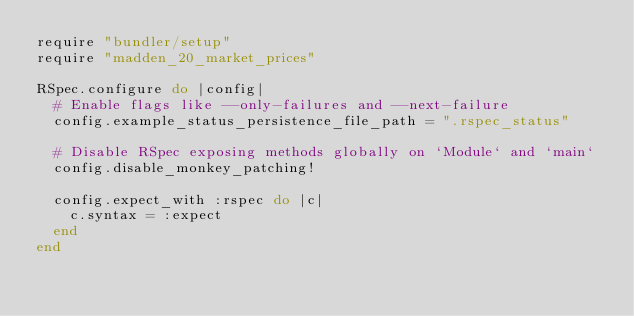<code> <loc_0><loc_0><loc_500><loc_500><_Ruby_>require "bundler/setup"
require "madden_20_market_prices"

RSpec.configure do |config|
  # Enable flags like --only-failures and --next-failure
  config.example_status_persistence_file_path = ".rspec_status"

  # Disable RSpec exposing methods globally on `Module` and `main`
  config.disable_monkey_patching!

  config.expect_with :rspec do |c|
    c.syntax = :expect
  end
end
</code> 